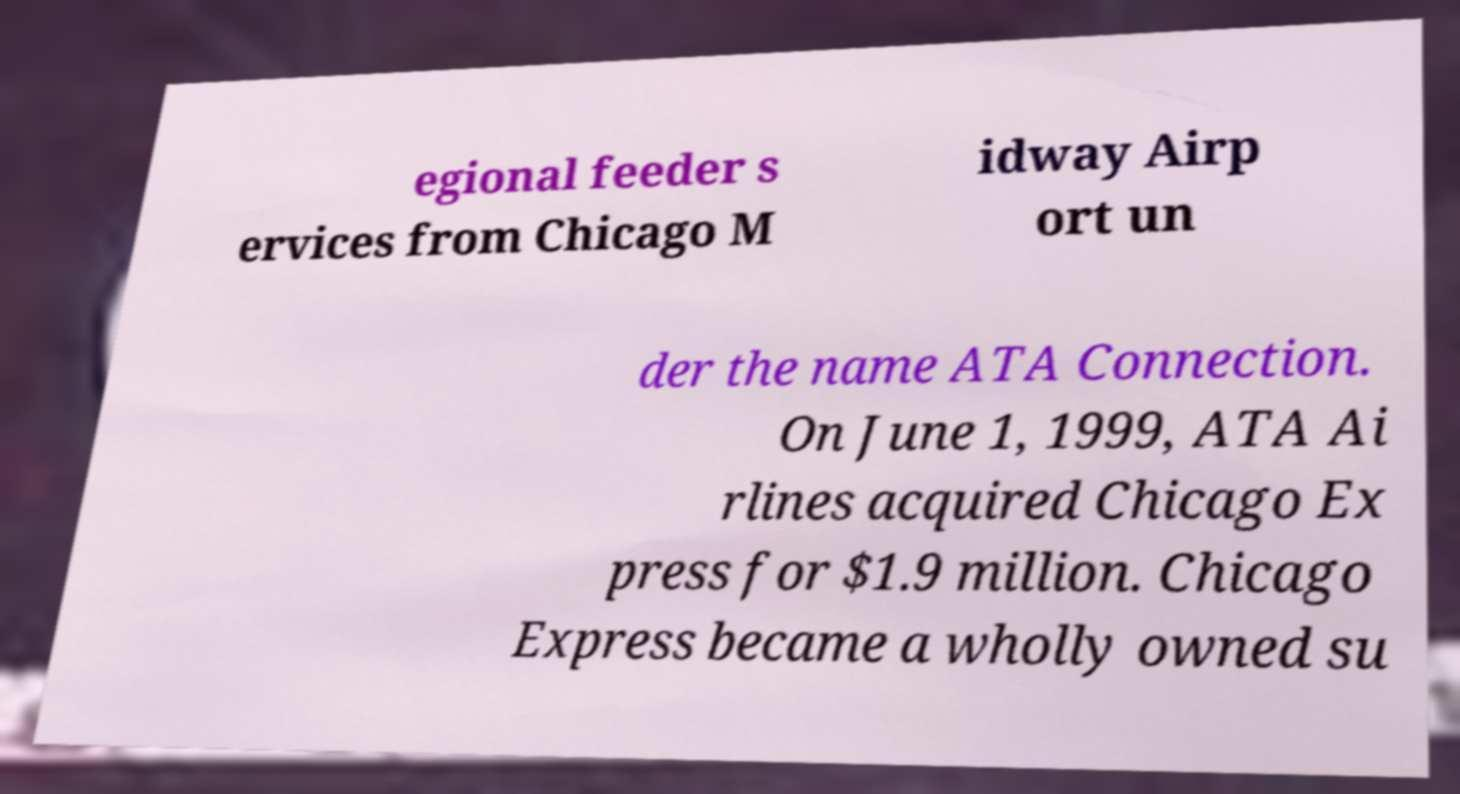Can you accurately transcribe the text from the provided image for me? egional feeder s ervices from Chicago M idway Airp ort un der the name ATA Connection. On June 1, 1999, ATA Ai rlines acquired Chicago Ex press for $1.9 million. Chicago Express became a wholly owned su 